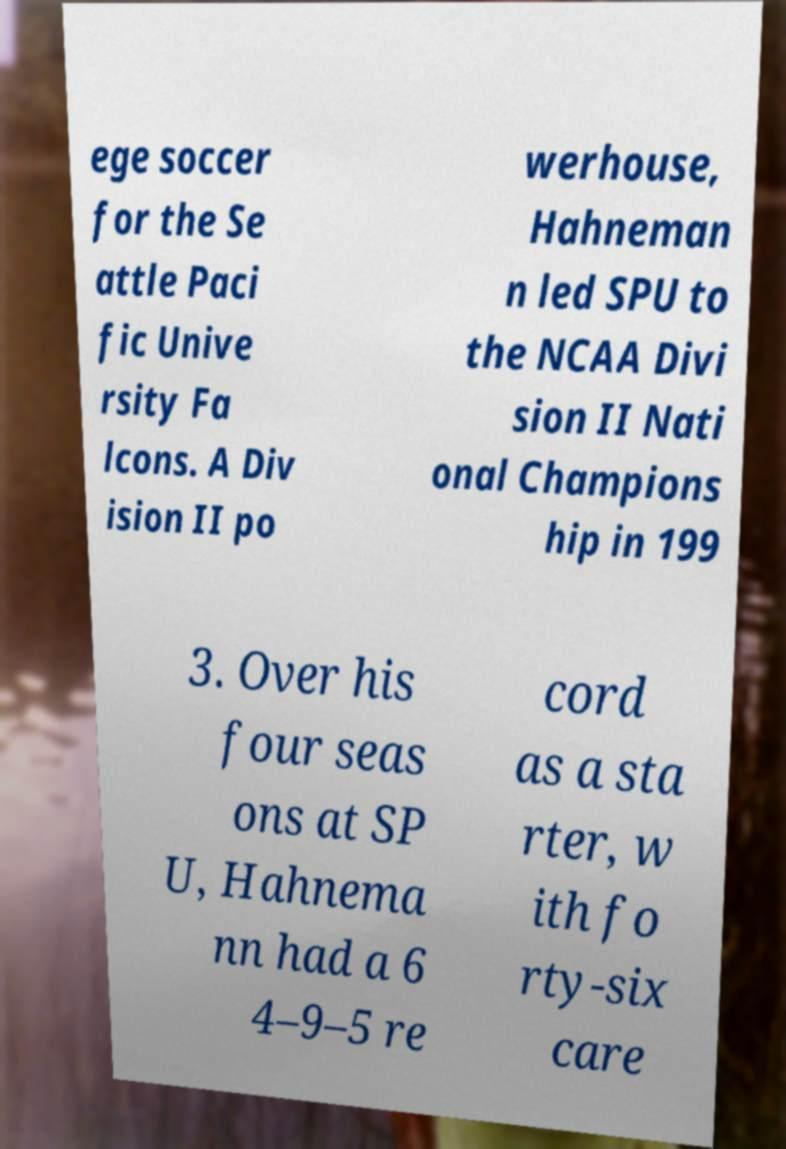Could you extract and type out the text from this image? ege soccer for the Se attle Paci fic Unive rsity Fa lcons. A Div ision II po werhouse, Hahneman n led SPU to the NCAA Divi sion II Nati onal Champions hip in 199 3. Over his four seas ons at SP U, Hahnema nn had a 6 4–9–5 re cord as a sta rter, w ith fo rty-six care 